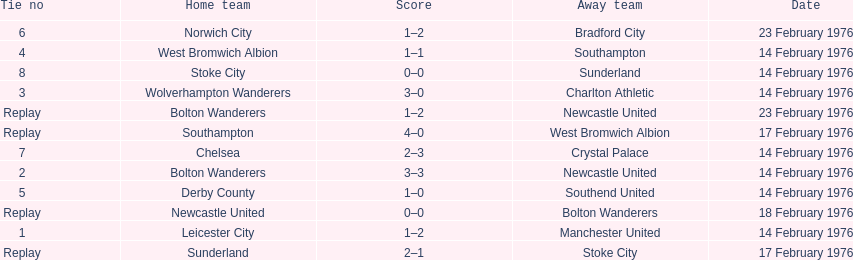What was the number of games that occurred on 14 february 1976? 7. Can you parse all the data within this table? {'header': ['Tie no', 'Home team', 'Score', 'Away team', 'Date'], 'rows': [['6', 'Norwich City', '1–2', 'Bradford City', '23 February 1976'], ['4', 'West Bromwich Albion', '1–1', 'Southampton', '14 February 1976'], ['8', 'Stoke City', '0–0', 'Sunderland', '14 February 1976'], ['3', 'Wolverhampton Wanderers', '3–0', 'Charlton Athletic', '14 February 1976'], ['Replay', 'Bolton Wanderers', '1–2', 'Newcastle United', '23 February 1976'], ['Replay', 'Southampton', '4–0', 'West Bromwich Albion', '17 February 1976'], ['7', 'Chelsea', '2–3', 'Crystal Palace', '14 February 1976'], ['2', 'Bolton Wanderers', '3–3', 'Newcastle United', '14 February 1976'], ['5', 'Derby County', '1–0', 'Southend United', '14 February 1976'], ['Replay', 'Newcastle United', '0–0', 'Bolton Wanderers', '18 February 1976'], ['1', 'Leicester City', '1–2', 'Manchester United', '14 February 1976'], ['Replay', 'Sunderland', '2–1', 'Stoke City', '17 February 1976']]} 